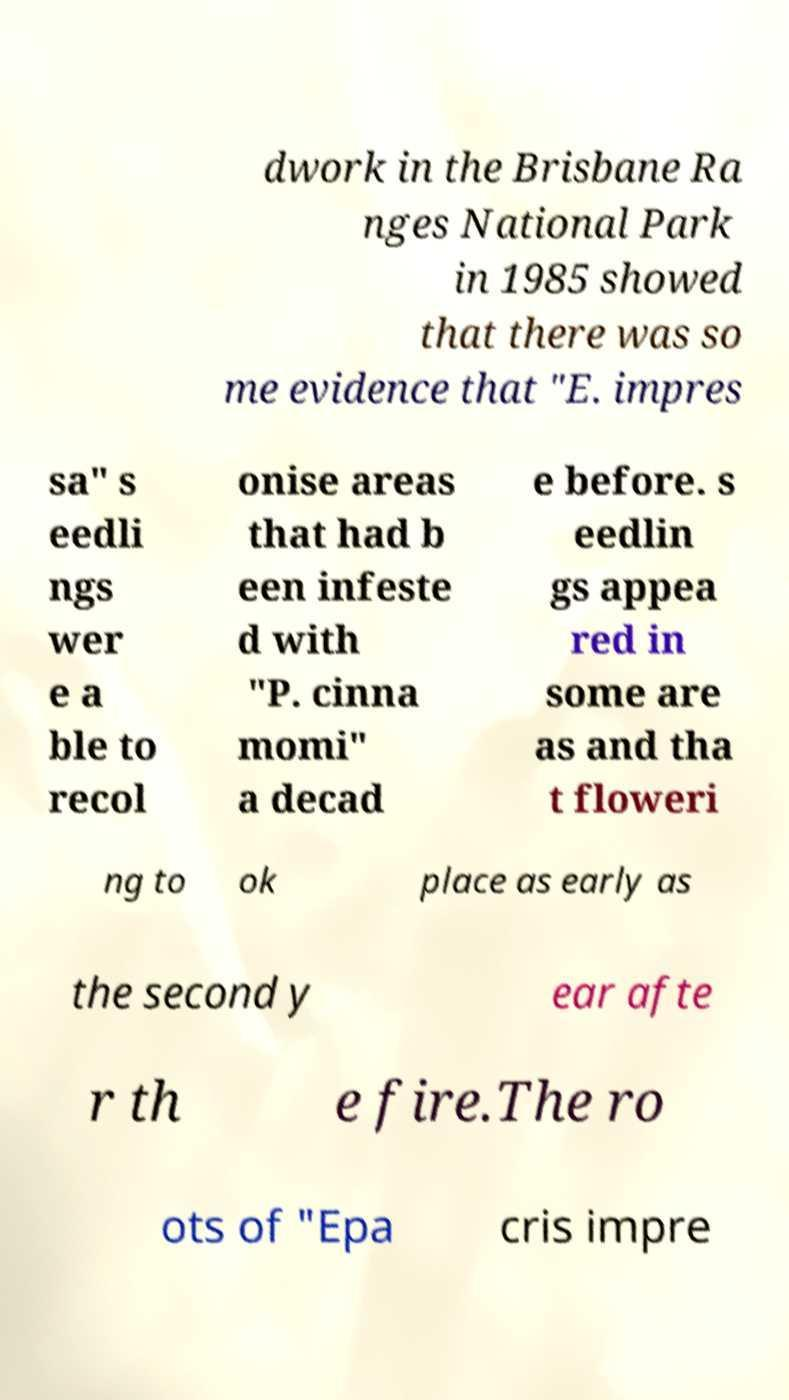For documentation purposes, I need the text within this image transcribed. Could you provide that? dwork in the Brisbane Ra nges National Park in 1985 showed that there was so me evidence that "E. impres sa" s eedli ngs wer e a ble to recol onise areas that had b een infeste d with "P. cinna momi" a decad e before. s eedlin gs appea red in some are as and tha t floweri ng to ok place as early as the second y ear afte r th e fire.The ro ots of "Epa cris impre 